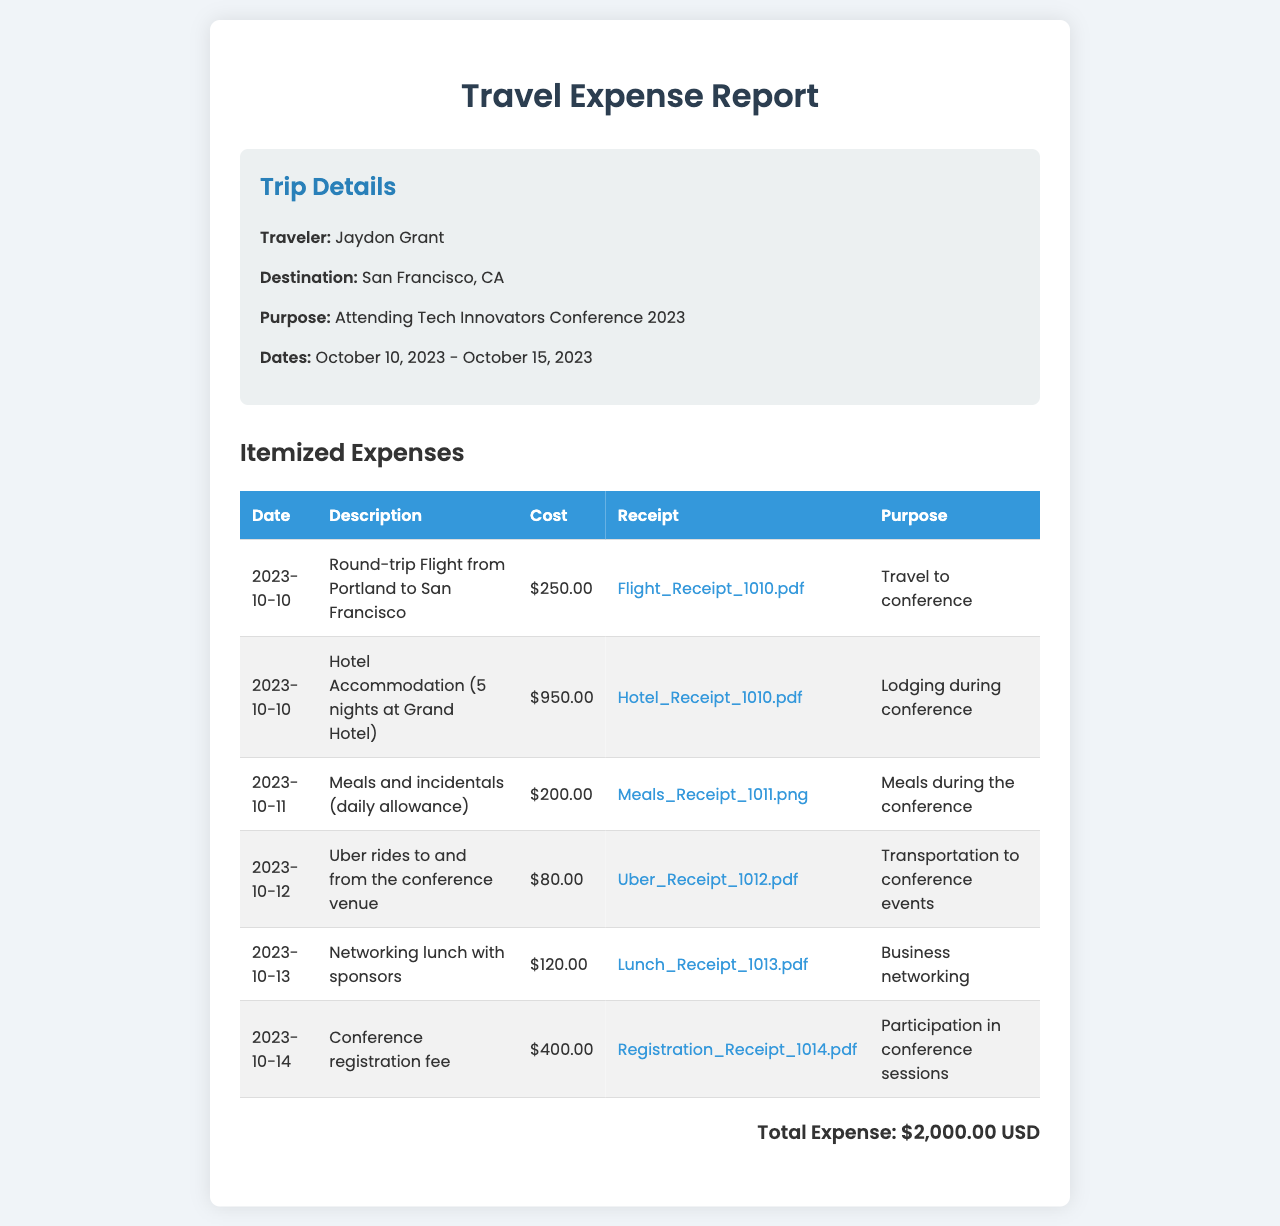What is the name of the traveler? The document states that the traveler's name is Jaydon Grant.
Answer: Jaydon Grant What is the total expense reported? The total expense is clearly stated at the bottom of the expenses section as $2,000.00 USD.
Answer: $2,000.00 USD What was the purpose of the trip? The purpose of the trip is outlined in the trip details section as attending the Tech Innovators Conference 2023.
Answer: Attending Tech Innovators Conference 2023 How much was spent on hotel accommodation? The document specifies that the hotel accommodation cost $950.00.
Answer: $950.00 On what date did the round-trip flight occur? According to the expenses table, the round-trip flight date is listed as 2023-10-10.
Answer: 2023-10-10 What was the cost of the conference registration fee? The document indicates that the registration fee for the conference was $400.00.
Answer: $400.00 What item was purchased on 2023-10-12? The expense listed for that date is for Uber rides to and from the conference venue.
Answer: Uber rides to and from the conference venue How many nights was the hotel accommodation for? The expense for hotel accommodation indicates it was for 5 nights at the Grand Hotel.
Answer: 5 nights What was the purpose of the networking lunch? The networking lunch's purpose is stated as business networking.
Answer: Business networking 